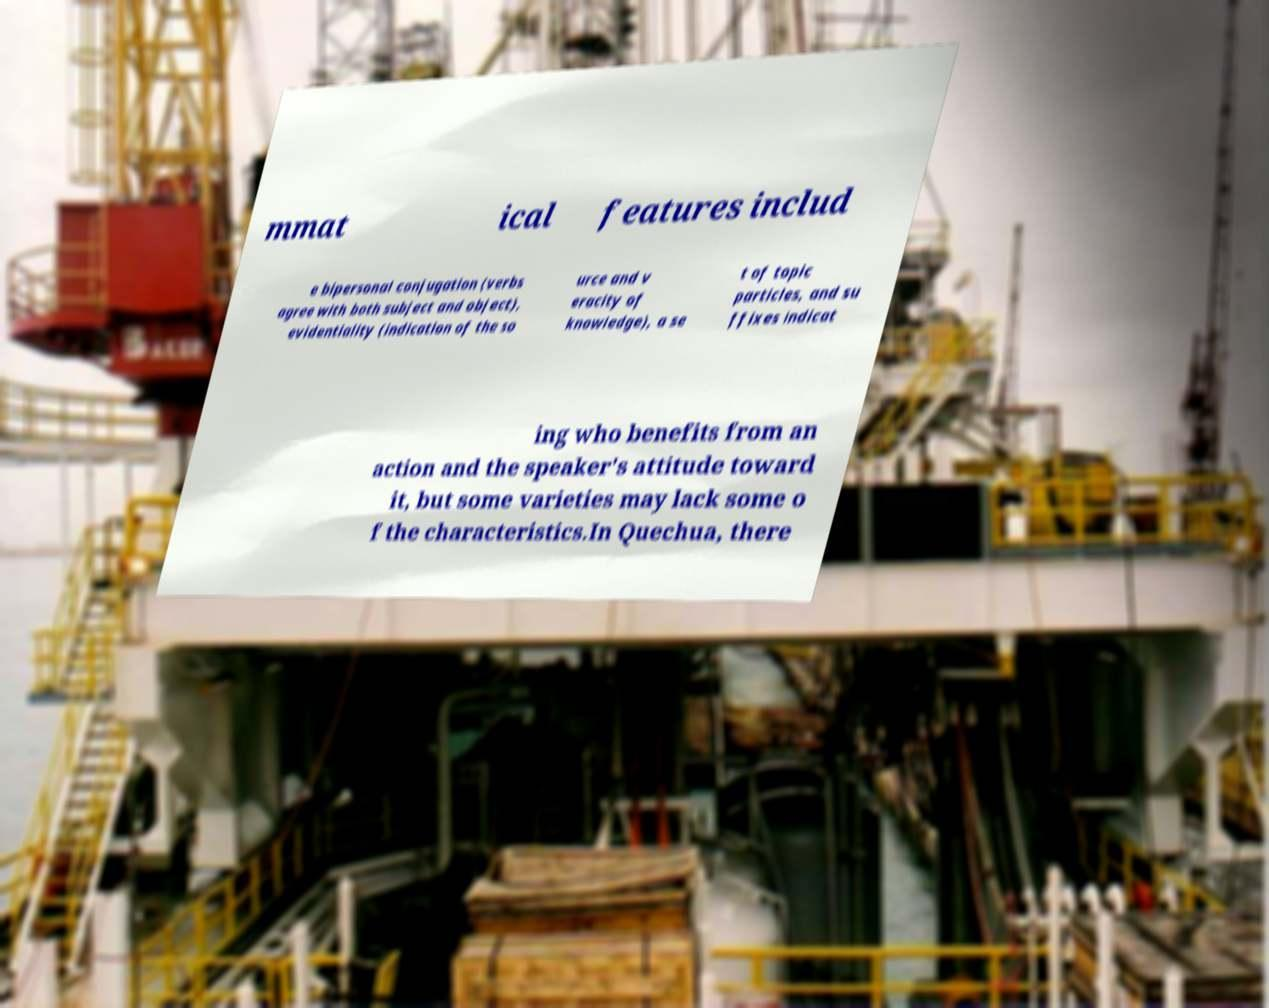I need the written content from this picture converted into text. Can you do that? mmat ical features includ e bipersonal conjugation (verbs agree with both subject and object), evidentiality (indication of the so urce and v eracity of knowledge), a se t of topic particles, and su ffixes indicat ing who benefits from an action and the speaker's attitude toward it, but some varieties may lack some o f the characteristics.In Quechua, there 